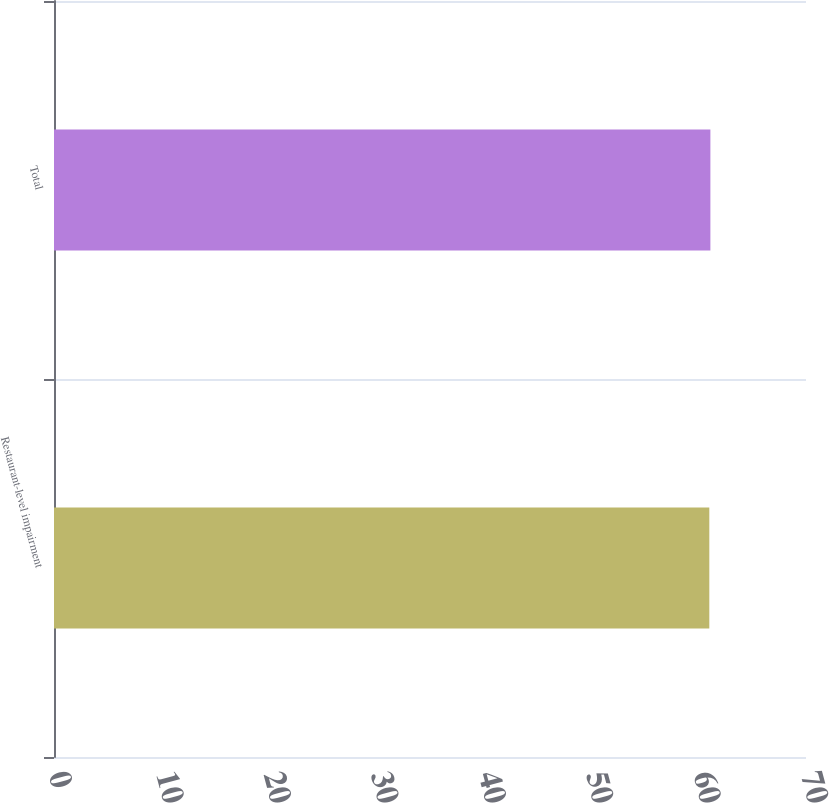Convert chart. <chart><loc_0><loc_0><loc_500><loc_500><bar_chart><fcel>Restaurant-level impairment<fcel>Total<nl><fcel>61<fcel>61.1<nl></chart> 